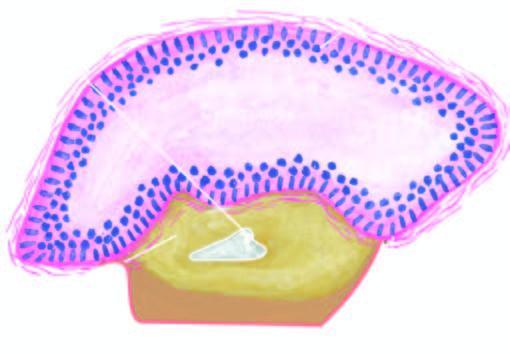where is a partly formed unerupted tooth seen in?
Answer the question using a single word or phrase. Wall 